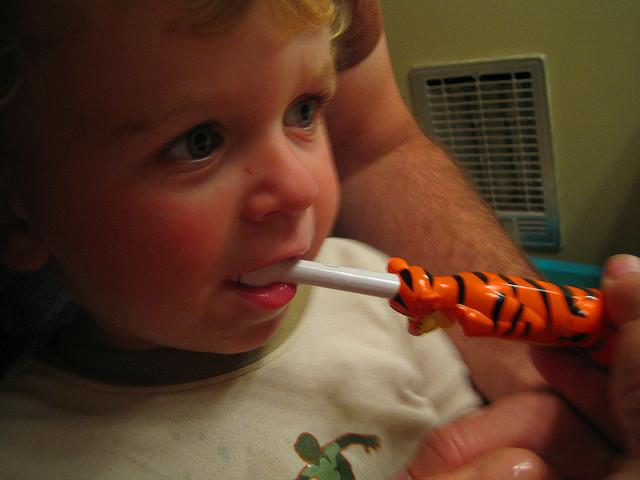What is on the end of tigger's head? Please explain your reasoning. toothbrush. This is in the child's mouth to clean his teeth 